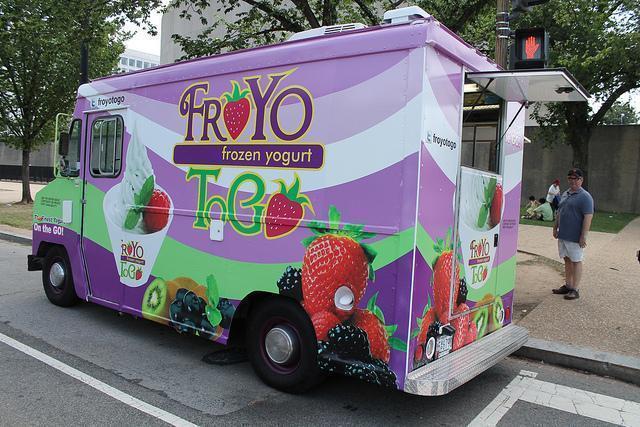What fruit is seen in the cup on the truck?
Select the accurate answer and provide explanation: 'Answer: answer
Rationale: rationale.'
Options: Mango, blueberry, raspberry, banana. Answer: raspberry.
Rationale: Though there are a number of fruits shown the main one is the raspberry. 